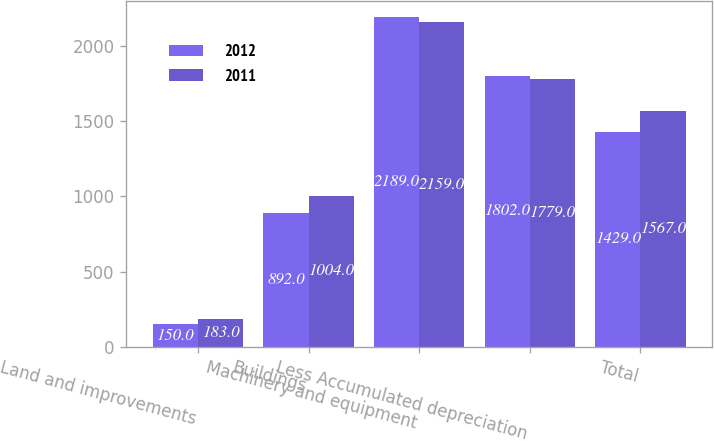Convert chart. <chart><loc_0><loc_0><loc_500><loc_500><stacked_bar_chart><ecel><fcel>Land and improvements<fcel>Buildings<fcel>Machinery and equipment<fcel>Less Accumulated depreciation<fcel>Total<nl><fcel>2012<fcel>150<fcel>892<fcel>2189<fcel>1802<fcel>1429<nl><fcel>2011<fcel>183<fcel>1004<fcel>2159<fcel>1779<fcel>1567<nl></chart> 